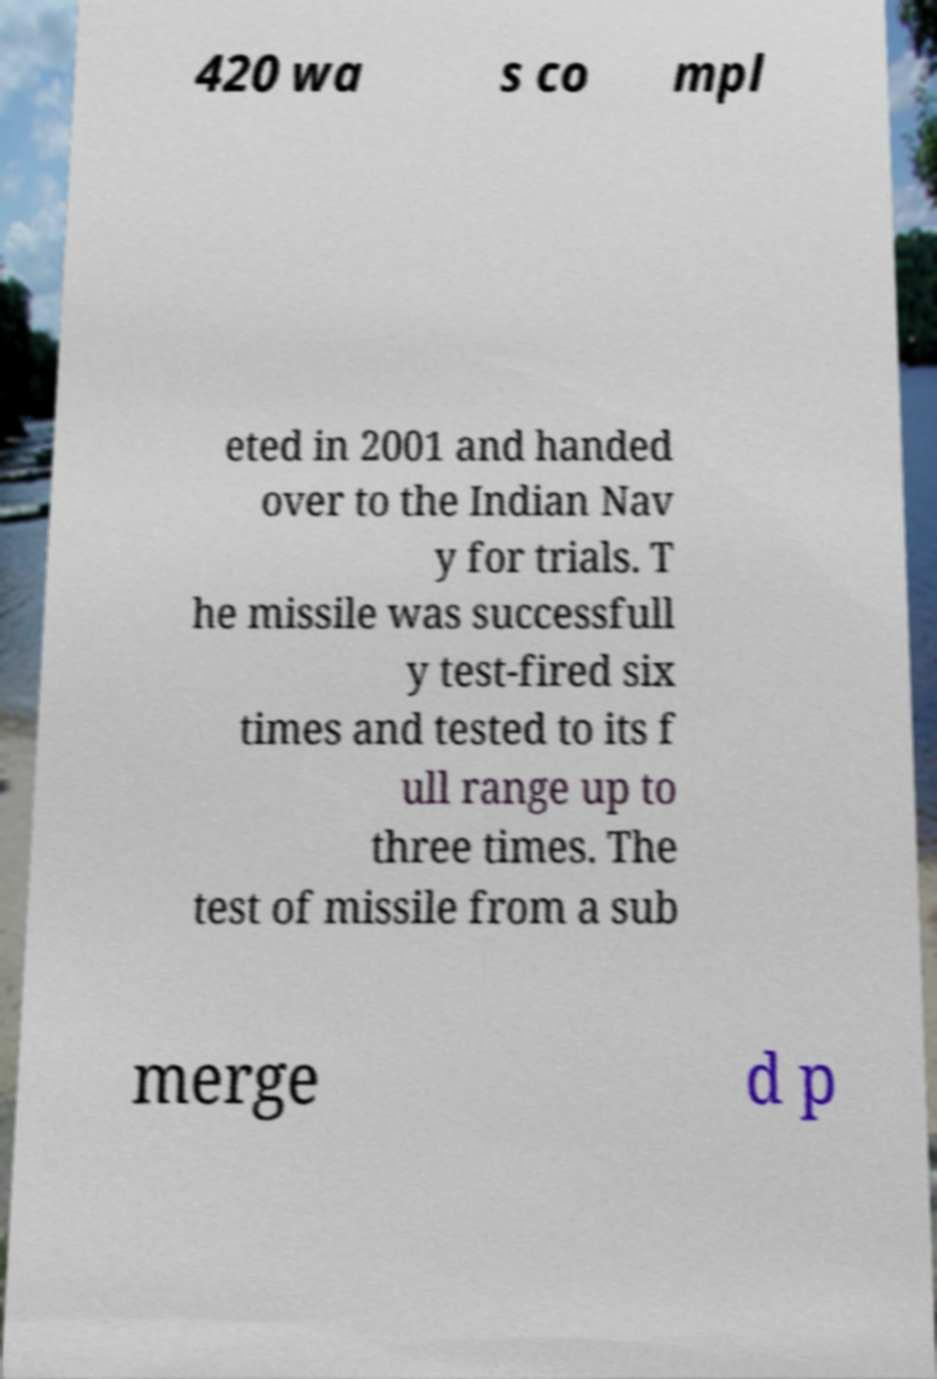What messages or text are displayed in this image? I need them in a readable, typed format. 420 wa s co mpl eted in 2001 and handed over to the Indian Nav y for trials. T he missile was successfull y test-fired six times and tested to its f ull range up to three times. The test of missile from a sub merge d p 